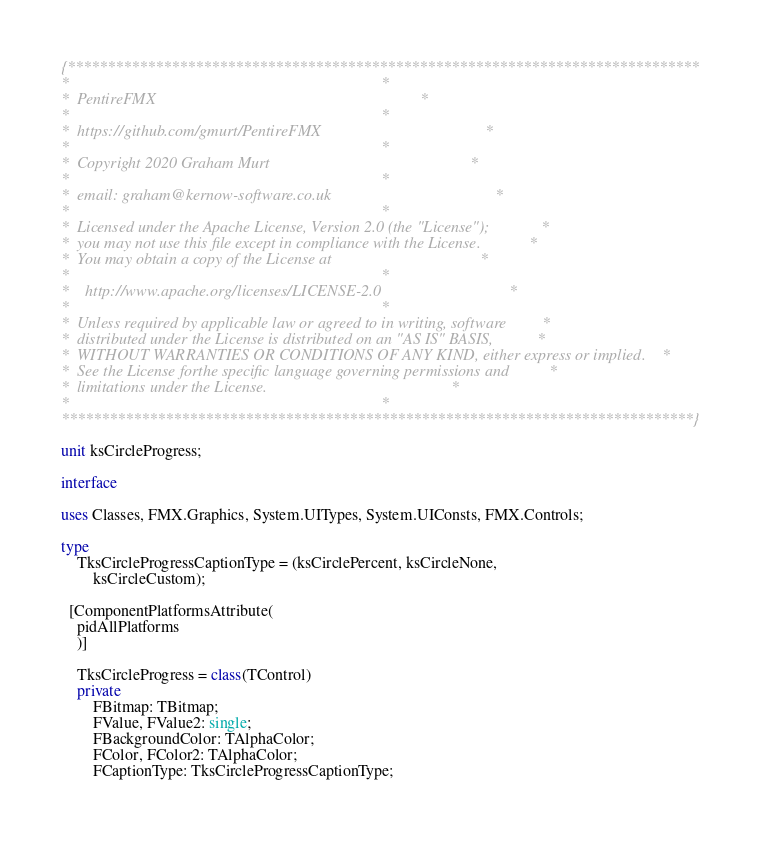Convert code to text. <code><loc_0><loc_0><loc_500><loc_500><_Pascal_>{*******************************************************************************
*                                                                              *
*  PentireFMX                                                                  *
*                                                                              *
*  https://github.com/gmurt/PentireFMX                                         *
*                                                                              *
*  Copyright 2020 Graham Murt                                                  *
*                                                                              *
*  email: graham@kernow-software.co.uk                                         *
*                                                                              *
*  Licensed under the Apache License, Version 2.0 (the "License");             *
*  you may not use this file except in compliance with the License.            *
*  You may obtain a copy of the License at                                     *
*                                                                              *
*    http://www.apache.org/licenses/LICENSE-2.0                                *
*                                                                              *
*  Unless required by applicable law or agreed to in writing, software         *
*  distributed under the License is distributed on an "AS IS" BASIS,           *
*  WITHOUT WARRANTIES OR CONDITIONS OF ANY KIND, either express or implied.    *
*  See the License forthe specific language governing permissions and          *
*  limitations under the License.                                              *
*                                                                              *
*******************************************************************************}

unit ksCircleProgress;

interface

uses Classes, FMX.Graphics, System.UITypes, System.UIConsts, FMX.Controls;

type
	TksCircleProgressCaptionType = (ksCirclePercent, ksCircleNone,
		ksCircleCustom);

  [ComponentPlatformsAttribute(
    pidAllPlatforms
    )]

	TksCircleProgress = class(TControl)
	private
		FBitmap: TBitmap;
		FValue, FValue2: single;
		FBackgroundColor: TAlphaColor;
		FColor, FColor2: TAlphaColor;
		FCaptionType: TksCircleProgressCaptionType;</code> 